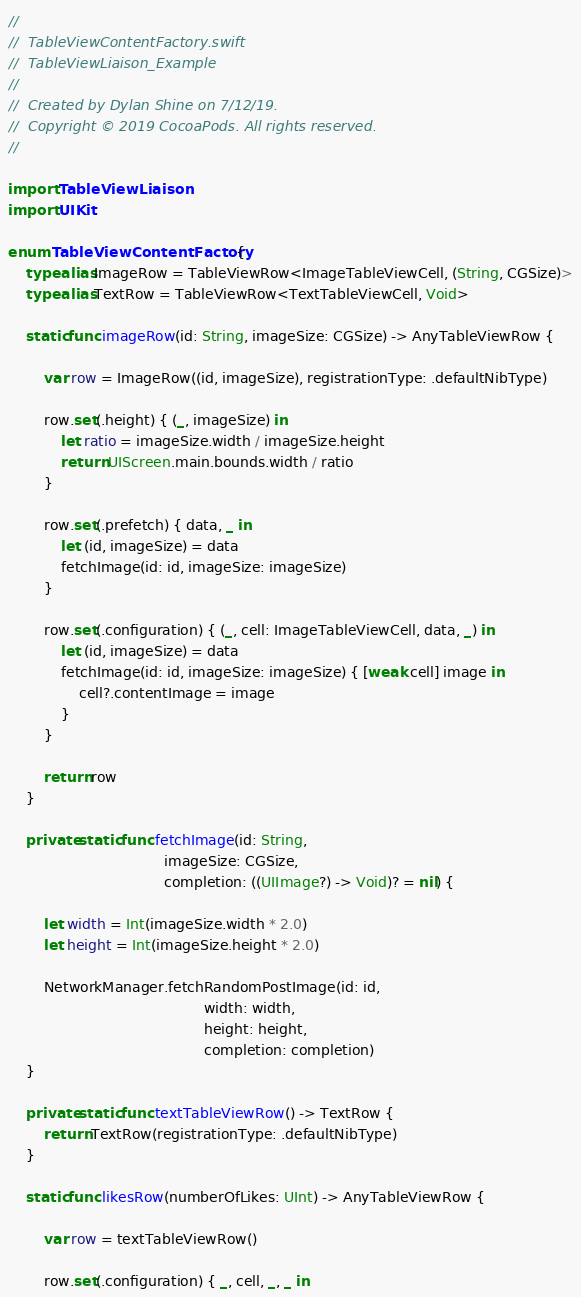<code> <loc_0><loc_0><loc_500><loc_500><_Swift_>//
//  TableViewContentFactory.swift
//  TableViewLiaison_Example
//
//  Created by Dylan Shine on 7/12/19.
//  Copyright © 2019 CocoaPods. All rights reserved.
//

import TableViewLiaison
import UIKit

enum TableViewContentFactory {
    typealias ImageRow = TableViewRow<ImageTableViewCell, (String, CGSize)>
    typealias TextRow = TableViewRow<TextTableViewCell, Void>

    static func imageRow(id: String, imageSize: CGSize) -> AnyTableViewRow {
        
        var row = ImageRow((id, imageSize), registrationType: .defaultNibType)
        
        row.set(.height) { (_, imageSize) in
            let ratio = imageSize.width / imageSize.height
            return UIScreen.main.bounds.width / ratio
        }
        
        row.set(.prefetch) { data, _ in
            let (id, imageSize) = data
            fetchImage(id: id, imageSize: imageSize)
        }
        
        row.set(.configuration) { (_, cell: ImageTableViewCell, data, _) in
            let (id, imageSize) = data
            fetchImage(id: id, imageSize: imageSize) { [weak cell] image in
                cell?.contentImage = image
            }
        }
        
        return row
    }
    
    private static func fetchImage(id: String,
                                   imageSize: CGSize,
                                   completion: ((UIImage?) -> Void)? = nil) {
        
        let width = Int(imageSize.width * 2.0)
        let height = Int(imageSize.height * 2.0)
        
        NetworkManager.fetchRandomPostImage(id: id,
                                            width: width,
                                            height: height,
                                            completion: completion)
    }
    
    private static func textTableViewRow() -> TextRow {
        return TextRow(registrationType: .defaultNibType)
    }
    
    static func likesRow(numberOfLikes: UInt) -> AnyTableViewRow {
        
        var row = textTableViewRow()
        
        row.set(.configuration) { _, cell, _, _ in</code> 